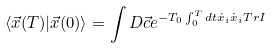Convert formula to latex. <formula><loc_0><loc_0><loc_500><loc_500>\langle \vec { x } ( T ) | \vec { x } ( 0 ) \rangle = \int D \vec { c } e ^ { - T _ { 0 } \int ^ { T } _ { 0 } d t \dot { x } _ { i } \dot { x } _ { i } T r I }</formula> 